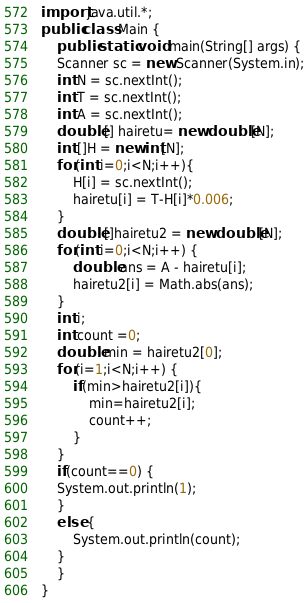Convert code to text. <code><loc_0><loc_0><loc_500><loc_500><_Java_>import java.util.*;
public class Main {
	public static void main(String[] args) {
	Scanner sc = new Scanner(System.in);
	int N = sc.nextInt();
	int T = sc.nextInt();
	int A = sc.nextInt();
	double [] hairetu= new double[N];
	int []H = new int[N];
	for(int i=0;i<N;i++){
	    H[i] = sc.nextInt(); 
		hairetu[i] = T-H[i]*0.006;
	}
	double []hairetu2 = new double[N];
	for(int i=0;i<N;i++) {
		double ans = A - hairetu[i];
		hairetu2[i] = Math.abs(ans);
	}
	int i;
	int count =0;
	double min = hairetu2[0];
	for(i=1;i<N;i++) {
		if(min>hairetu2[i]){
			min=hairetu2[i];
			count++;
		}
	}
	if(count==0) {
	System.out.println(1);
	}
	else {
		System.out.println(count);
	}
	}
}
</code> 